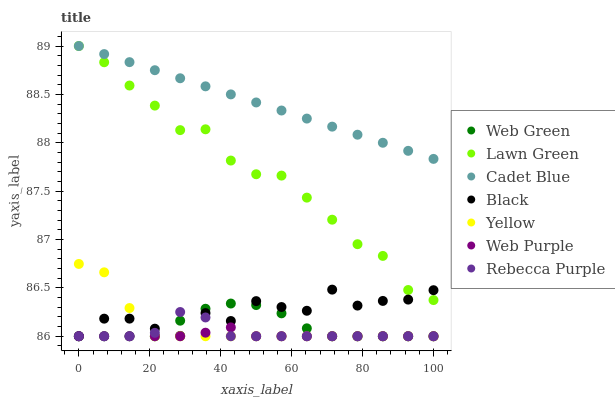Does Web Purple have the minimum area under the curve?
Answer yes or no. Yes. Does Cadet Blue have the maximum area under the curve?
Answer yes or no. Yes. Does Yellow have the minimum area under the curve?
Answer yes or no. No. Does Yellow have the maximum area under the curve?
Answer yes or no. No. Is Cadet Blue the smoothest?
Answer yes or no. Yes. Is Black the roughest?
Answer yes or no. Yes. Is Yellow the smoothest?
Answer yes or no. No. Is Yellow the roughest?
Answer yes or no. No. Does Yellow have the lowest value?
Answer yes or no. Yes. Does Cadet Blue have the lowest value?
Answer yes or no. No. Does Cadet Blue have the highest value?
Answer yes or no. Yes. Does Yellow have the highest value?
Answer yes or no. No. Is Web Green less than Cadet Blue?
Answer yes or no. Yes. Is Lawn Green greater than Web Purple?
Answer yes or no. Yes. Does Lawn Green intersect Cadet Blue?
Answer yes or no. Yes. Is Lawn Green less than Cadet Blue?
Answer yes or no. No. Is Lawn Green greater than Cadet Blue?
Answer yes or no. No. Does Web Green intersect Cadet Blue?
Answer yes or no. No. 